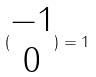<formula> <loc_0><loc_0><loc_500><loc_500>( \begin{matrix} - 1 \\ 0 \end{matrix} ) = 1</formula> 